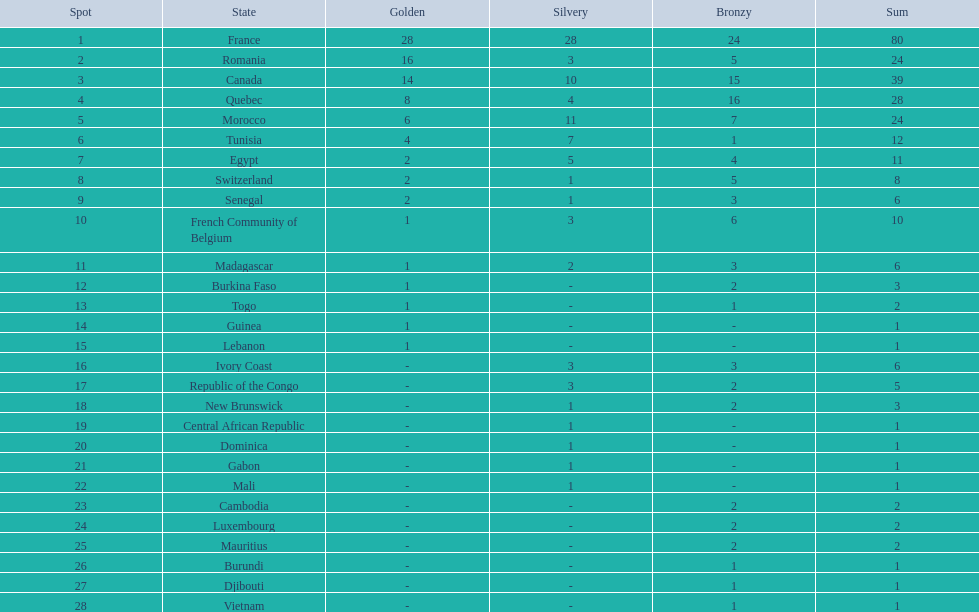What was the total medal count of switzerland? 8. 